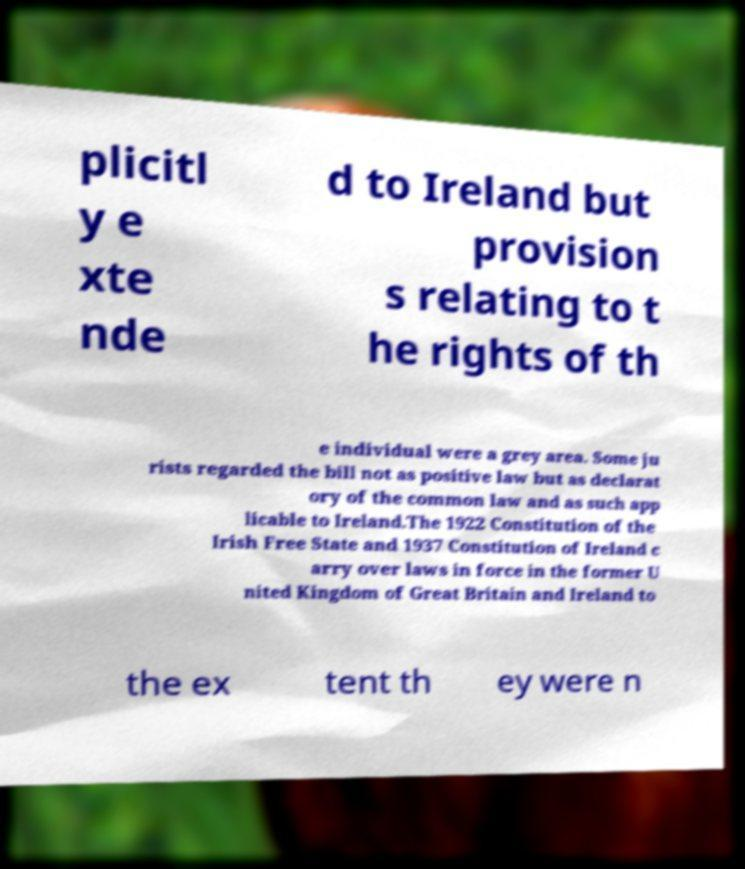Can you accurately transcribe the text from the provided image for me? plicitl y e xte nde d to Ireland but provision s relating to t he rights of th e individual were a grey area. Some ju rists regarded the bill not as positive law but as declarat ory of the common law and as such app licable to Ireland.The 1922 Constitution of the Irish Free State and 1937 Constitution of Ireland c arry over laws in force in the former U nited Kingdom of Great Britain and Ireland to the ex tent th ey were n 